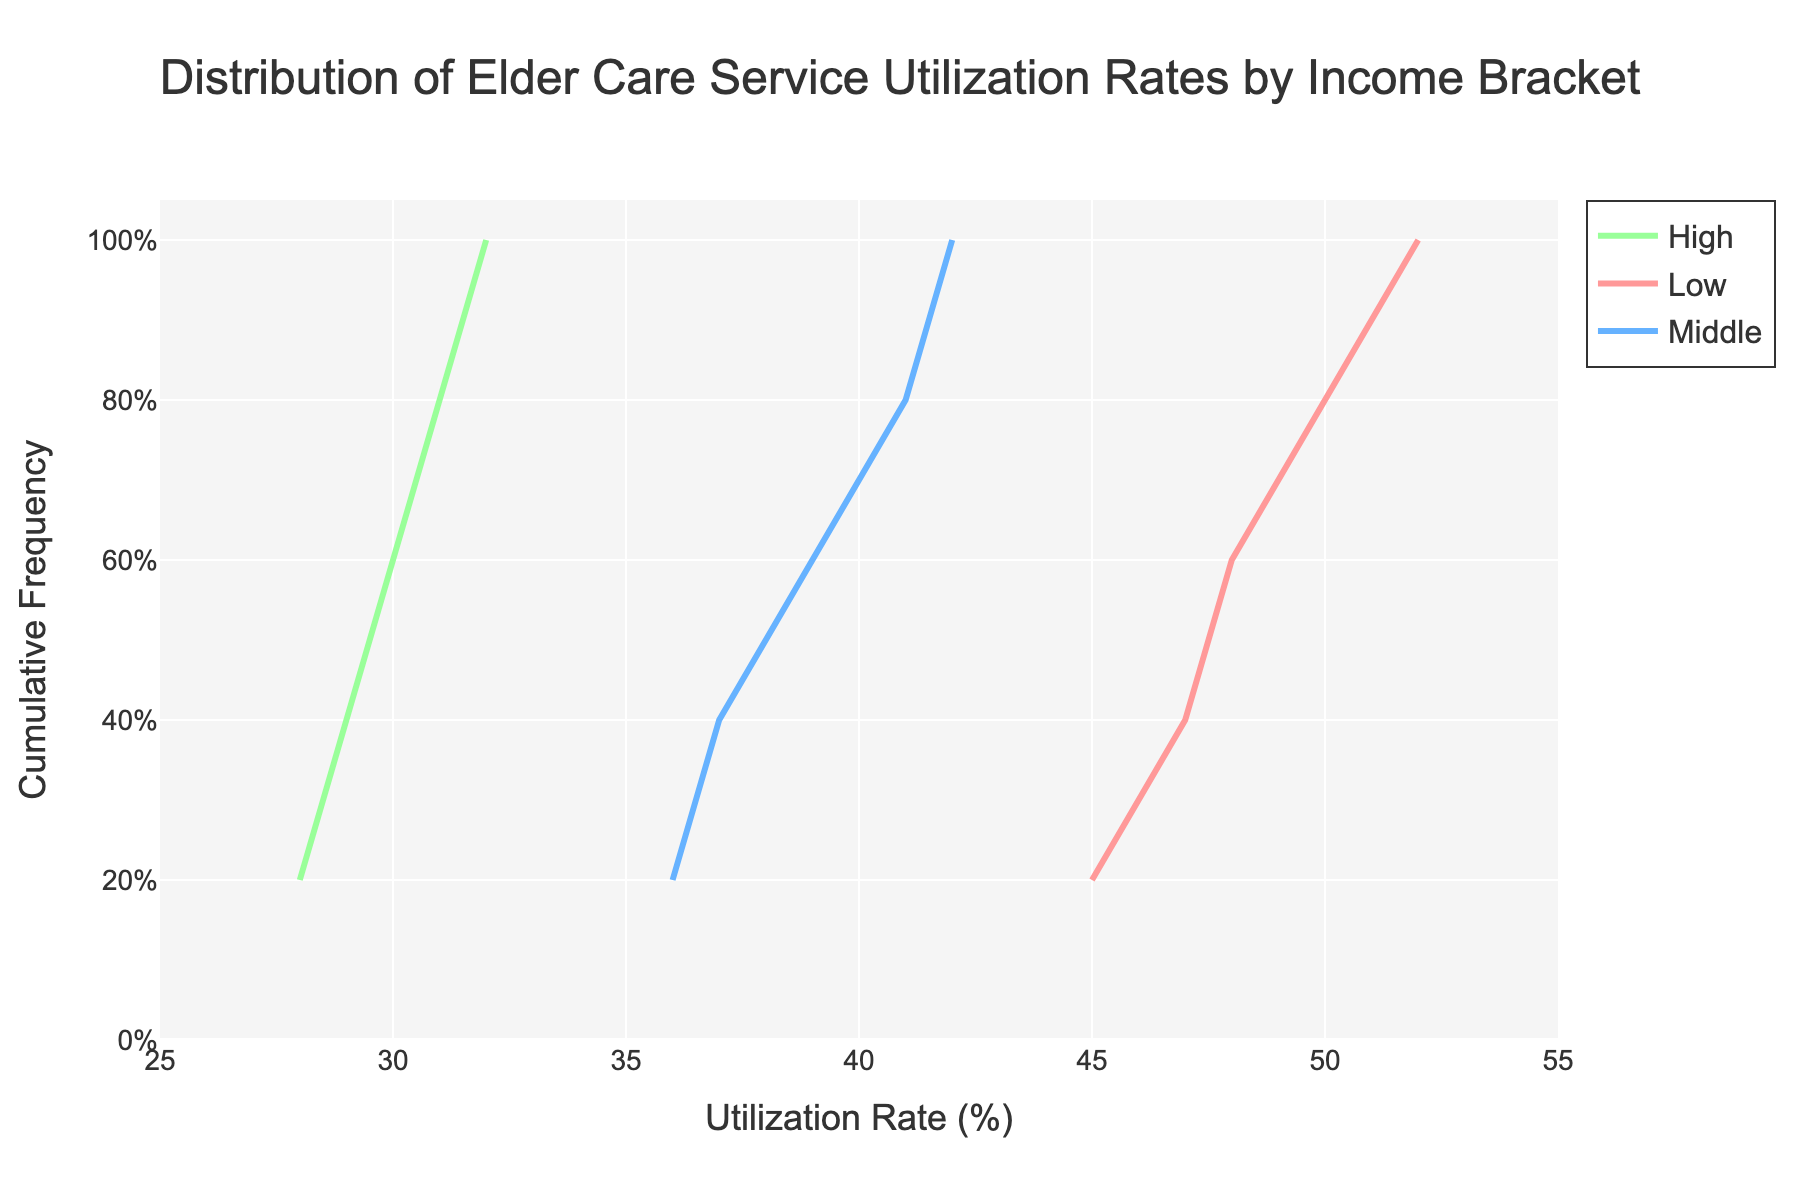What is the title of the stair plot? The title is displayed at the top of the figure and it helps to understand the general topic of the plot.
Answer: Distribution of Elder Care Service Utilization Rates by Income Bracket What is the cumulative frequency for the low-income bracket when the utilization rate is 50%? Locate the line corresponding to the low-income bracket, then find the point where the utilization rate is 50% on the x-axis and check the corresponding y-axis value.
Answer: 80% Which income bracket shows the highest utilization rate? By looking at the rightmost points of each line, the highest utilization rate corresponds to the highest x-axis value among the lines.
Answer: Low What is the range of utilization rates for the middle-income bracket? The range can be found by identifying the minimum and maximum x-axis values for the middle-income bracket line. The minimum is the leftmost point and the maximum is the rightmost point.
Answer: 36% to 42% Compare the median utilization rates of the low and high-income brackets. Which one is higher? The median utilization rate can be located at the 50% cumulative frequency (y-axis = 0.5) for each income bracket. For the low-income bracket, this aligns around 48%. For the high-income bracket, it is around 30%.
Answer: Low At what utilization rate do the low and middle-income brackets have the same cumulative frequency? Find the point where the lines for the low and middle-income brackets intersect and note the x-axis value at this intersection.
Answer: 42% What utilization rate corresponds to the 60th percentile for the high-income bracket? Locate the point on the high-income bracket line where the y-axis value is 0.6 and check the corresponding x-axis value.
Answer: 30% Which income bracket has the most spread in utilization rates? The spread can be gauged by looking at the distance between the smallest and largest x-axis values for each line. The low-income bracket has the largest range from 45% to 52%.
Answer: Low 